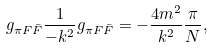Convert formula to latex. <formula><loc_0><loc_0><loc_500><loc_500>g _ { \pi F \bar { F } } \frac { 1 } { - k ^ { 2 } } g _ { \pi F \bar { F } } = - \frac { 4 m ^ { 2 } } { k ^ { 2 } } \frac { \pi } { N } ,</formula> 